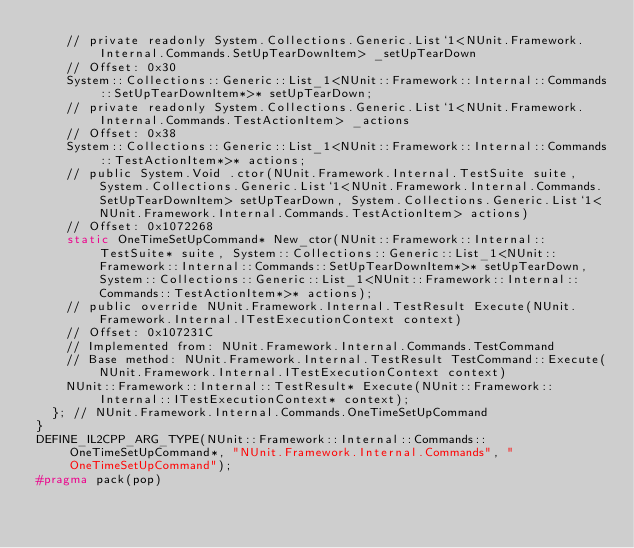Convert code to text. <code><loc_0><loc_0><loc_500><loc_500><_C++_>    // private readonly System.Collections.Generic.List`1<NUnit.Framework.Internal.Commands.SetUpTearDownItem> _setUpTearDown
    // Offset: 0x30
    System::Collections::Generic::List_1<NUnit::Framework::Internal::Commands::SetUpTearDownItem*>* setUpTearDown;
    // private readonly System.Collections.Generic.List`1<NUnit.Framework.Internal.Commands.TestActionItem> _actions
    // Offset: 0x38
    System::Collections::Generic::List_1<NUnit::Framework::Internal::Commands::TestActionItem*>* actions;
    // public System.Void .ctor(NUnit.Framework.Internal.TestSuite suite, System.Collections.Generic.List`1<NUnit.Framework.Internal.Commands.SetUpTearDownItem> setUpTearDown, System.Collections.Generic.List`1<NUnit.Framework.Internal.Commands.TestActionItem> actions)
    // Offset: 0x1072268
    static OneTimeSetUpCommand* New_ctor(NUnit::Framework::Internal::TestSuite* suite, System::Collections::Generic::List_1<NUnit::Framework::Internal::Commands::SetUpTearDownItem*>* setUpTearDown, System::Collections::Generic::List_1<NUnit::Framework::Internal::Commands::TestActionItem*>* actions);
    // public override NUnit.Framework.Internal.TestResult Execute(NUnit.Framework.Internal.ITestExecutionContext context)
    // Offset: 0x107231C
    // Implemented from: NUnit.Framework.Internal.Commands.TestCommand
    // Base method: NUnit.Framework.Internal.TestResult TestCommand::Execute(NUnit.Framework.Internal.ITestExecutionContext context)
    NUnit::Framework::Internal::TestResult* Execute(NUnit::Framework::Internal::ITestExecutionContext* context);
  }; // NUnit.Framework.Internal.Commands.OneTimeSetUpCommand
}
DEFINE_IL2CPP_ARG_TYPE(NUnit::Framework::Internal::Commands::OneTimeSetUpCommand*, "NUnit.Framework.Internal.Commands", "OneTimeSetUpCommand");
#pragma pack(pop)
</code> 